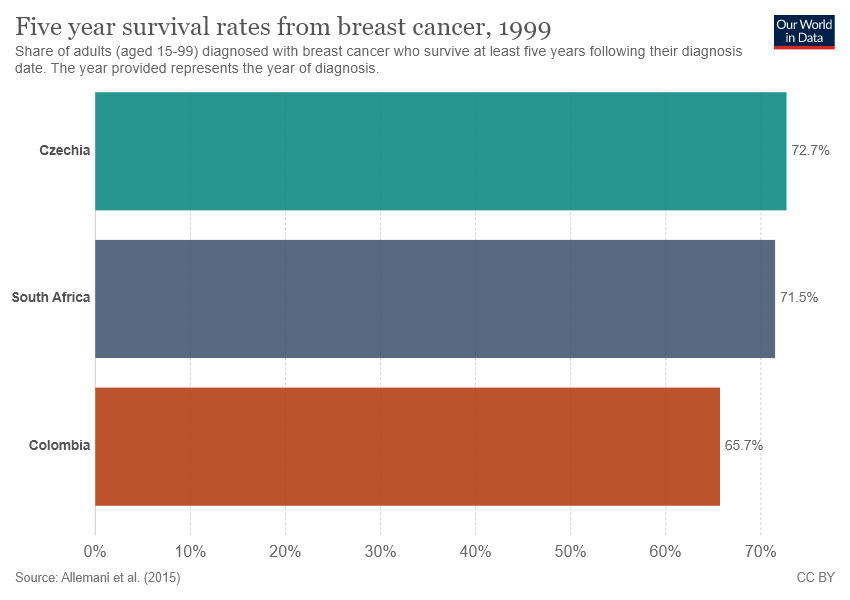Point out several critical features in this image. South Africa is represented by the middle bar. The difference in the values of the uppermost and middle bar is smaller than the difference in the values of the middle and lowermost bar, which means that the distribution of the data is more symmetrical around the mean. 